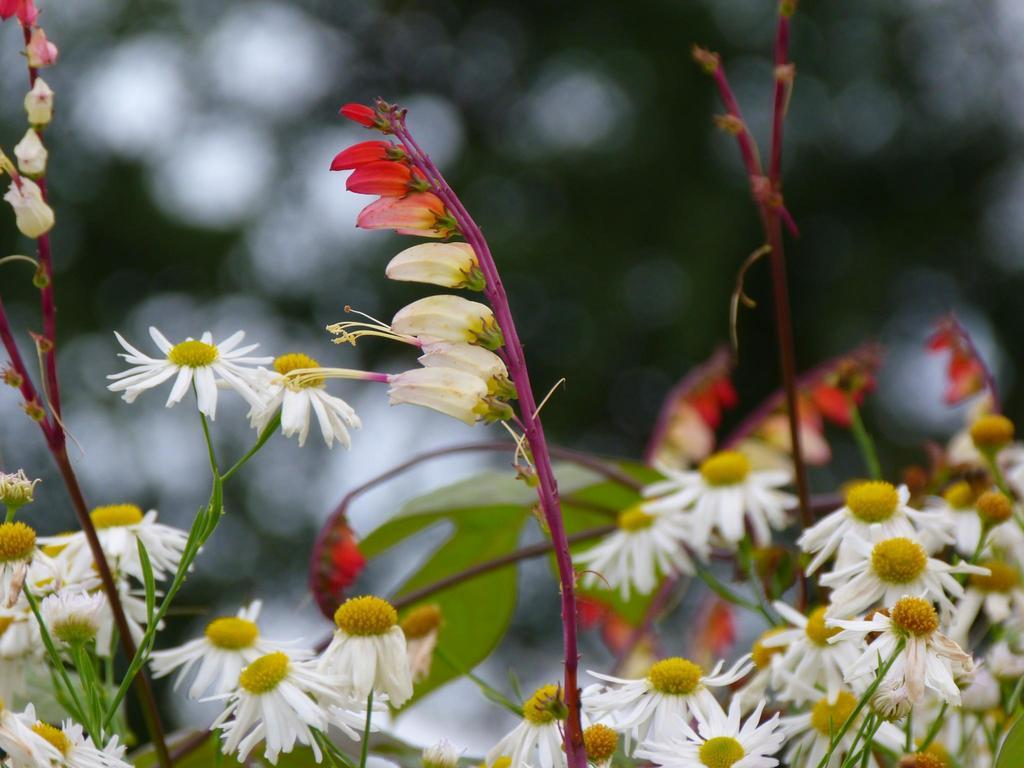What type of living organisms can be seen in the image? There are flowers and plants in the image. Can you describe the plants in the image? The plants in the image are not specified, but they are present alongside the flowers. How much does the fly weigh in the image? There is no fly present in the image, so its weight cannot be determined. 